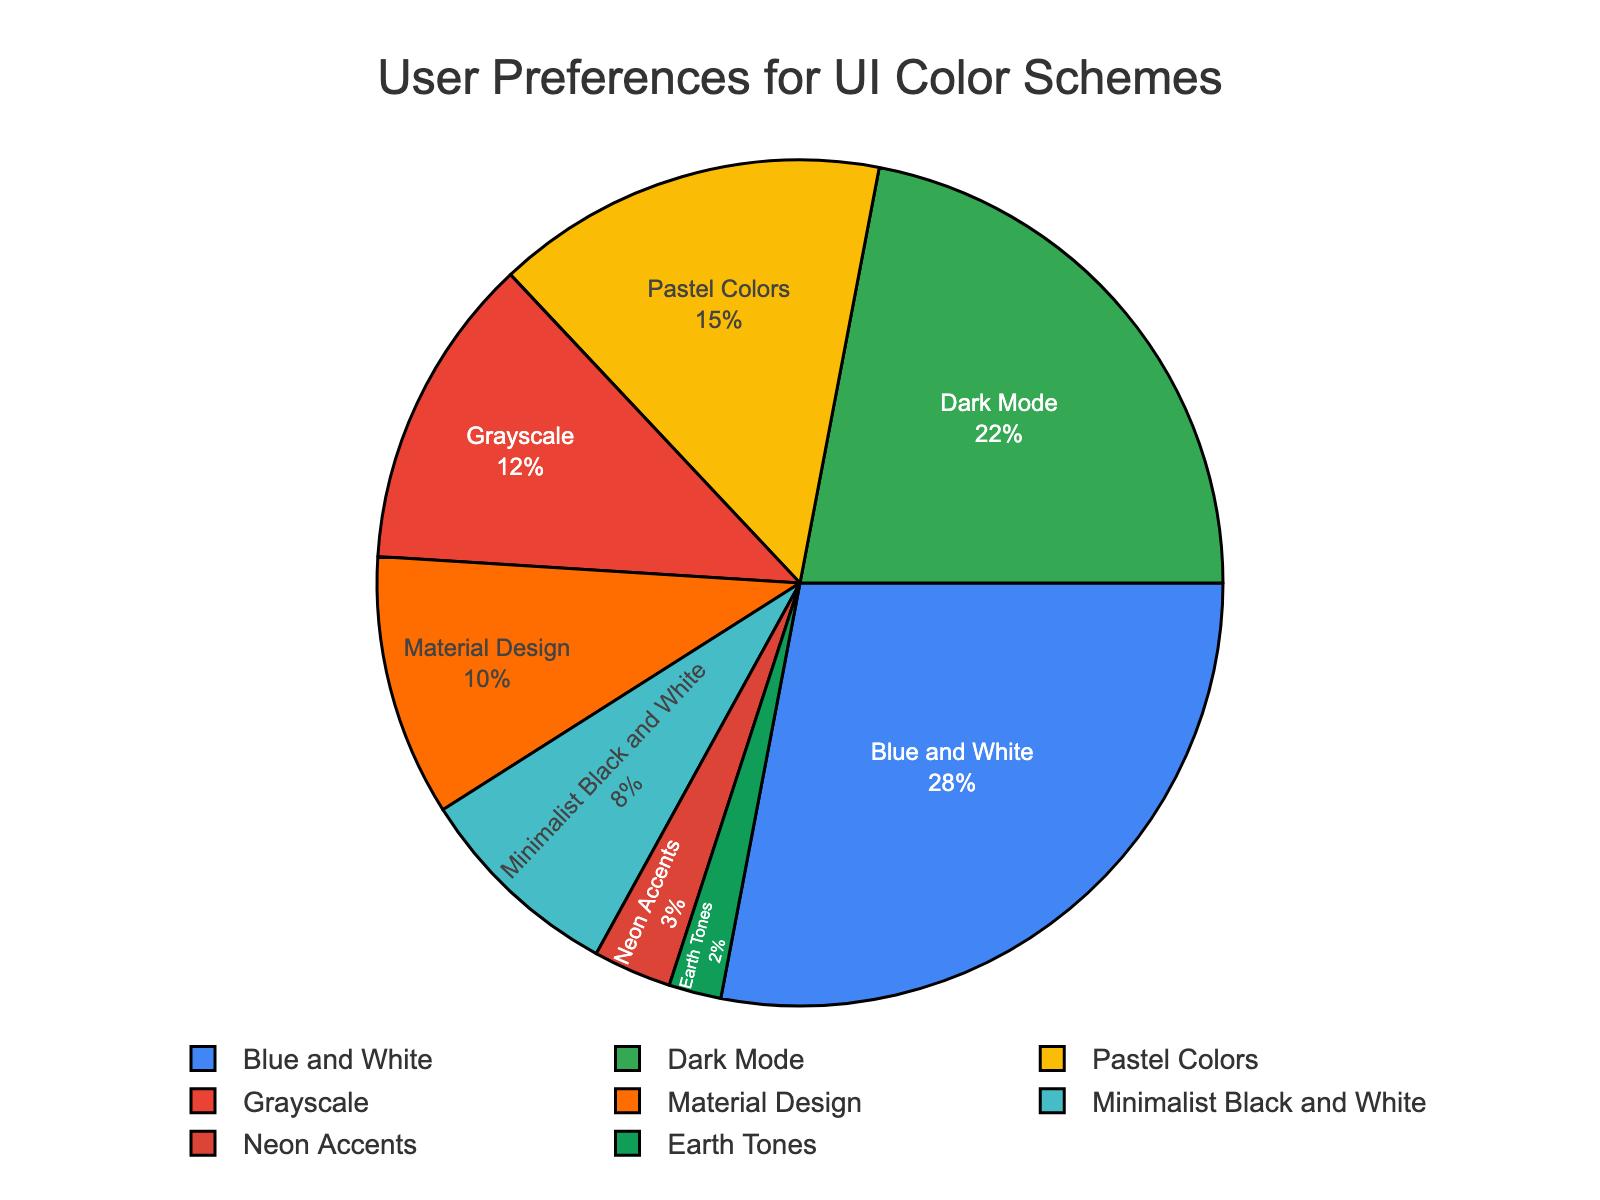What's the most popular UI color scheme? The majority section on the pie chart has the highest percentage. Blue and White has the largest portion with 28%.
Answer: Blue and White Which color scheme has the smallest user preference? Look for the section with the smallest percentage. Earth Tones has the least with 2%.
Answer: Earth Tones How does Dark Mode compare to Blue and White in terms of preference? The percentages are 22% for Dark Mode and 28% for Blue and White. Blue and White has a higher preference.
Answer: Blue and White is more preferred What is the combined user preference for Minimalist Black and White and Neon Accents? Sum the percentages of Minimalist Black and White (8%) and Neon Accents (3%). 8% + 3% equals 11%.
Answer: 11% Are there more users who prefer Grayscale or Material Design? Compare the percentages for Grayscale (12%) and Material Design (10%). Grayscale has a higher percentage.
Answer: Grayscale What's the percentage difference between the users preferring Pastel Colors and Earth Tones? Subtract the Earth Tones percentage (2%) from Pastel Colors (15%). 15% - 2% equals 13%.
Answer: 13% Which color schemes have preference percentages that are within 5% of each other? Look for the sections with close percentages. Material Design (10%) and Minimalist Black and White (8%) are within 5% of each other.
Answer: Material Design and Minimalist Black and White What percentage of users prefer either Grayscale or Dark Mode? Sum the percentages of Grayscale (12%) and Dark Mode (22%). 12% + 22% equals 34%.
Answer: 34% Does any single color scheme account for more than a quarter of user preferences? Check if any percentage is greater than 25%. Blue and White has 28%, which is more than a quarter.
Answer: Yes, Blue and White How many color schemes have a user preference of more than 10%? Count the sections with more than 10%. There are four: Blue and White (28%), Dark Mode (22%), Pastel Colors (15%), and Grayscale (12%).
Answer: Four 